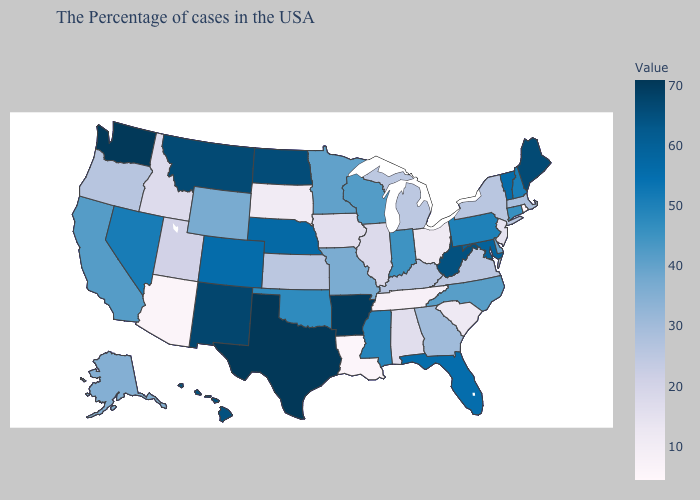Does New Mexico have the highest value in the USA?
Keep it brief. No. Is the legend a continuous bar?
Keep it brief. Yes. Among the states that border Indiana , does Ohio have the lowest value?
Keep it brief. Yes. Among the states that border Illinois , does Kentucky have the lowest value?
Concise answer only. No. 